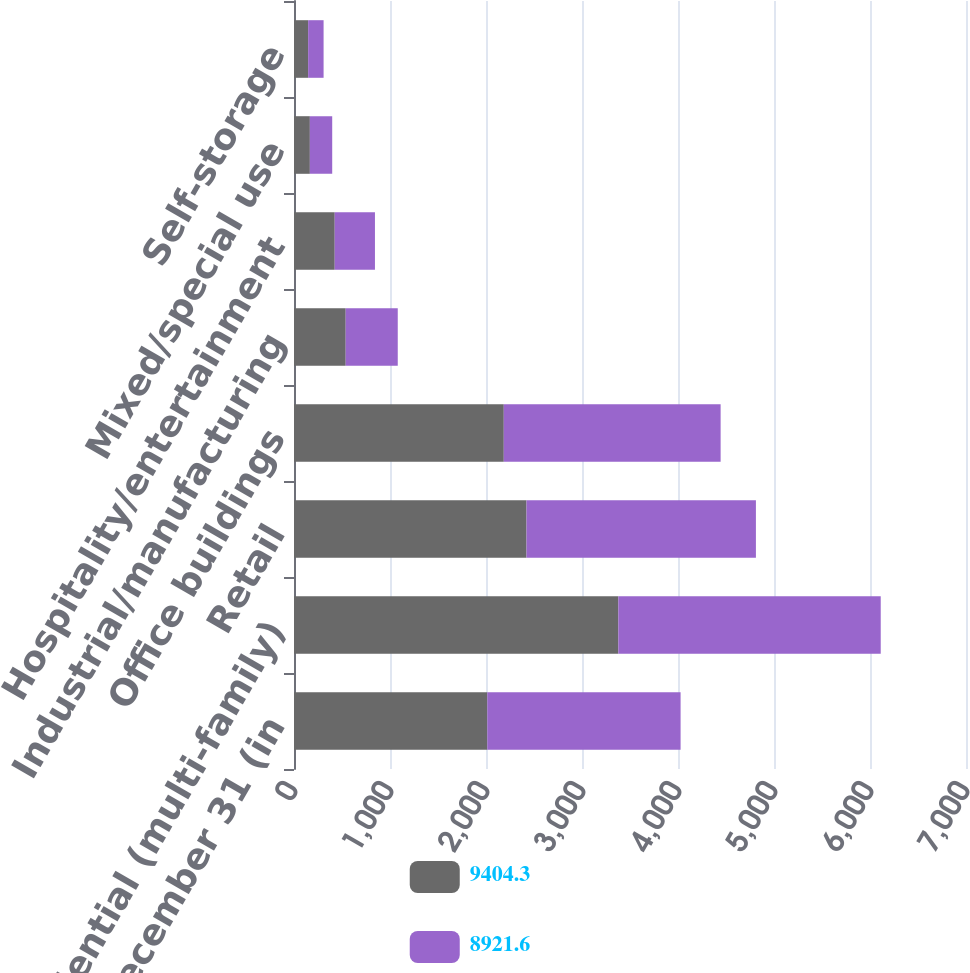Convert chart to OTSL. <chart><loc_0><loc_0><loc_500><loc_500><stacked_bar_chart><ecel><fcel>As of December 31 (in<fcel>Residential (multi-family)<fcel>Retail<fcel>Office buildings<fcel>Industrial/manufacturing<fcel>Hospitality/entertainment<fcel>Mixed/special use<fcel>Self-storage<nl><fcel>9404.3<fcel>2014<fcel>3378.4<fcel>2422<fcel>2185.3<fcel>538.6<fcel>424.2<fcel>165.2<fcel>147.3<nl><fcel>8921.6<fcel>2013<fcel>2733.3<fcel>2389.6<fcel>2258.7<fcel>542.2<fcel>419.1<fcel>232.8<fcel>160.9<nl></chart> 